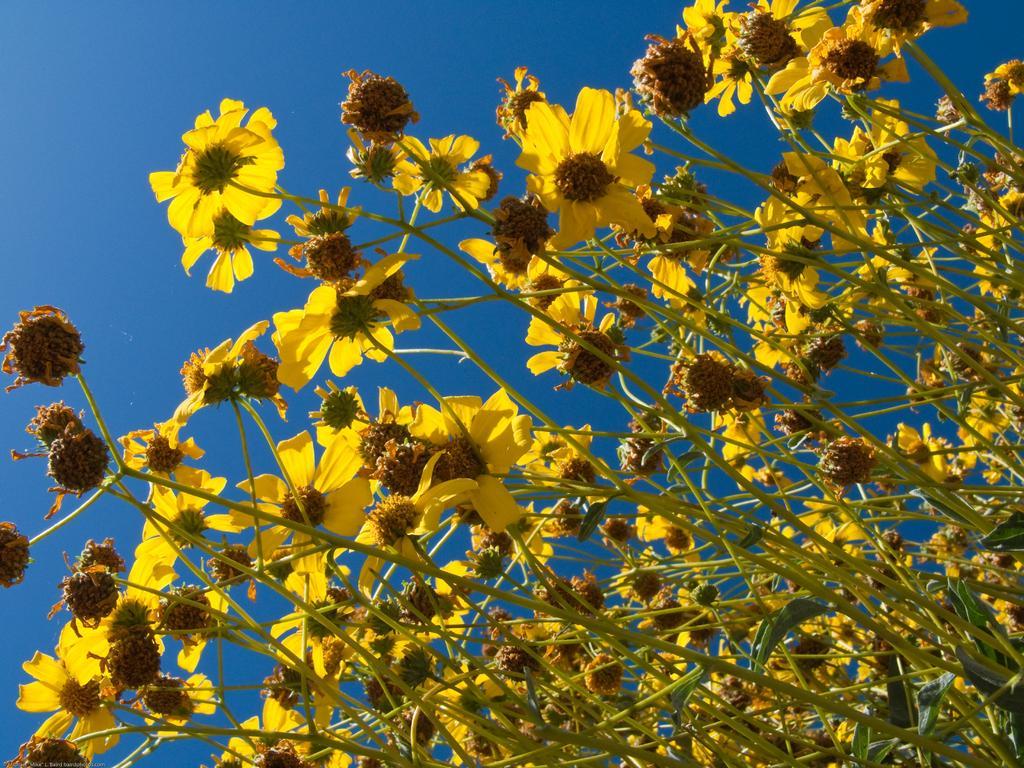Please provide a concise description of this image. In this picture, I can see yellow color flowers with stem and sky which is in blue. 